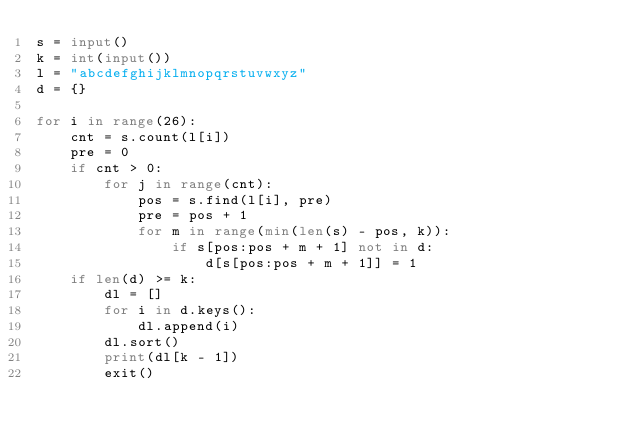Convert code to text. <code><loc_0><loc_0><loc_500><loc_500><_Python_>s = input()
k = int(input())
l = "abcdefghijklmnopqrstuvwxyz"
d = {}

for i in range(26):
    cnt = s.count(l[i])
    pre = 0
    if cnt > 0:
        for j in range(cnt):
            pos = s.find(l[i], pre)
            pre = pos + 1
            for m in range(min(len(s) - pos, k)):
                if s[pos:pos + m + 1] not in d:
                    d[s[pos:pos + m + 1]] = 1
    if len(d) >= k:
        dl = []
        for i in d.keys():
            dl.append(i)
        dl.sort()
        print(dl[k - 1])
        exit()</code> 